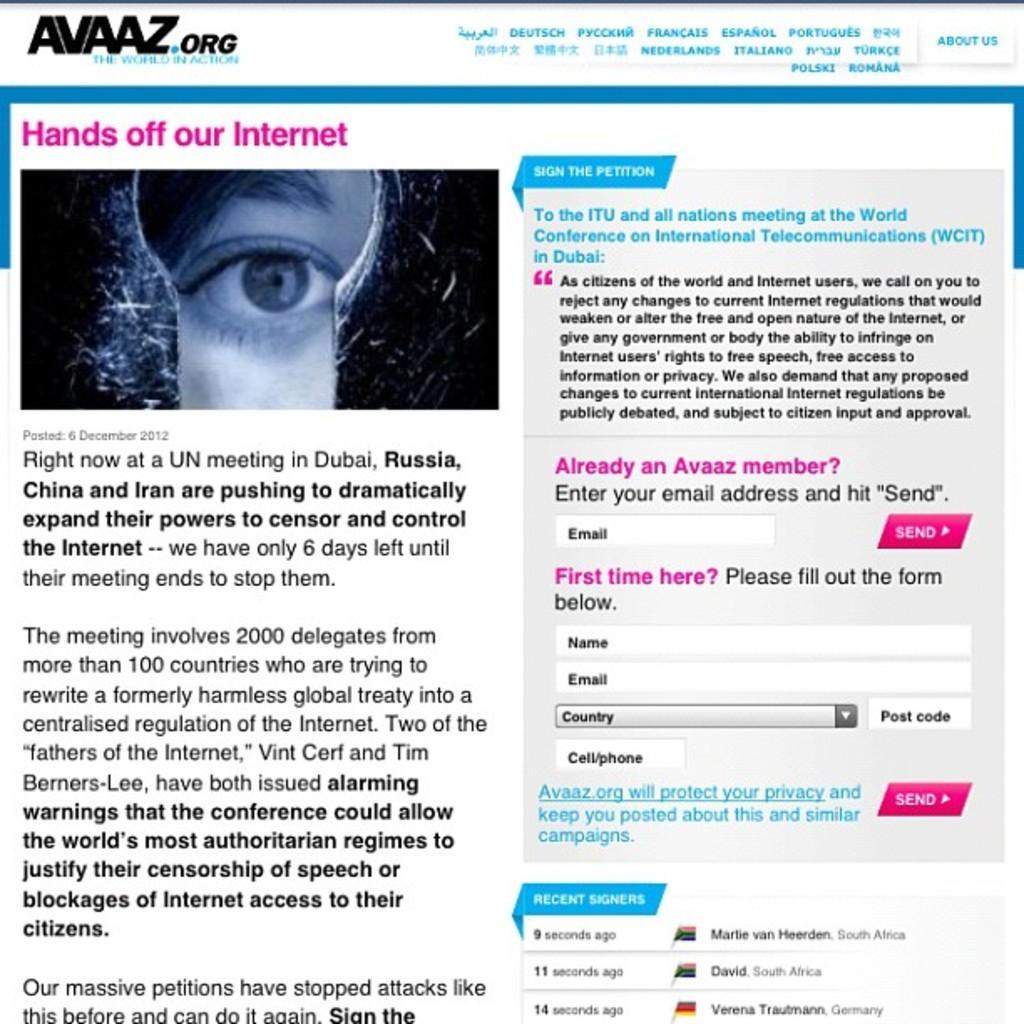In one or two sentences, can you explain what this image depicts? In this image I can see something is written on the left and on the right side of this image. I can also see a eye of a person on the top left side this image. 